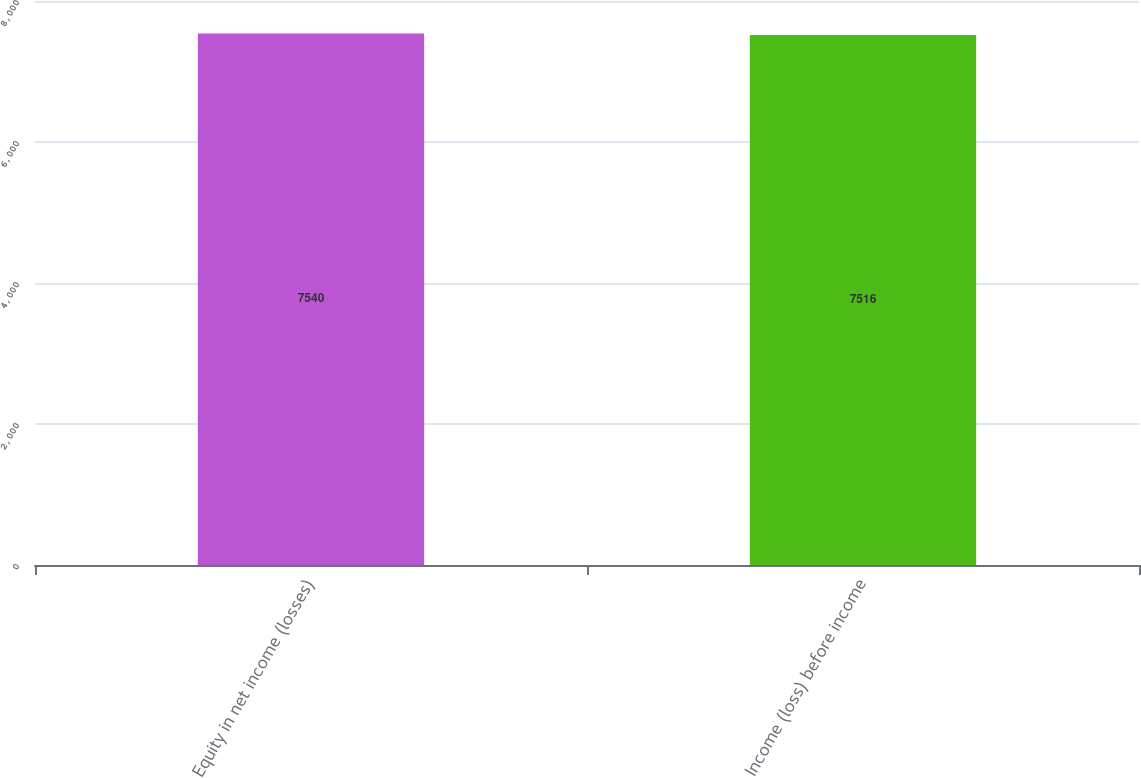Convert chart. <chart><loc_0><loc_0><loc_500><loc_500><bar_chart><fcel>Equity in net income (losses)<fcel>Income (loss) before income<nl><fcel>7540<fcel>7516<nl></chart> 